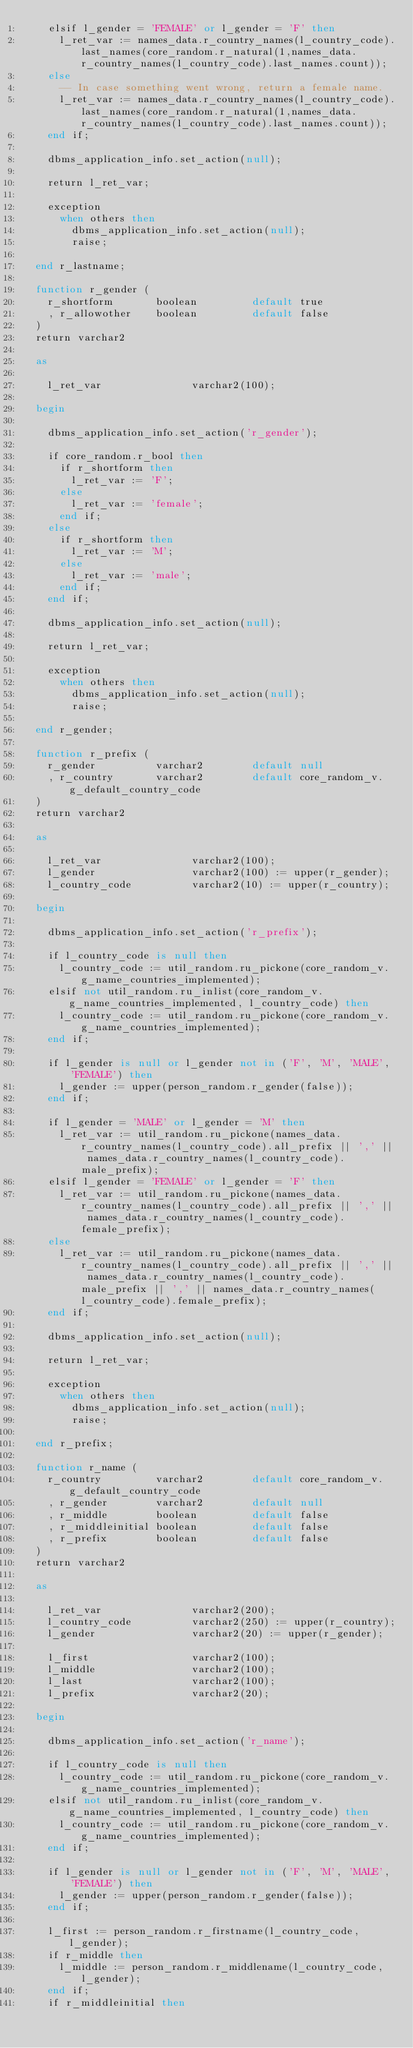Convert code to text. <code><loc_0><loc_0><loc_500><loc_500><_SQL_>    elsif l_gender = 'FEMALE' or l_gender = 'F' then
      l_ret_var := names_data.r_country_names(l_country_code).last_names(core_random.r_natural(1,names_data.r_country_names(l_country_code).last_names.count));
    else
      -- In case something went wrong, return a female name.
      l_ret_var := names_data.r_country_names(l_country_code).last_names(core_random.r_natural(1,names_data.r_country_names(l_country_code).last_names.count));
    end if;

    dbms_application_info.set_action(null);

    return l_ret_var;

    exception
      when others then
        dbms_application_info.set_action(null);
        raise;

  end r_lastname;

  function r_gender (
    r_shortform       boolean         default true
    , r_allowother    boolean         default false
  )
  return varchar2

  as

    l_ret_var               varchar2(100);

  begin

    dbms_application_info.set_action('r_gender');

    if core_random.r_bool then
      if r_shortform then
        l_ret_var := 'F';
      else
        l_ret_var := 'female';
      end if;
    else
      if r_shortform then
        l_ret_var := 'M';
      else
        l_ret_var := 'male';
      end if;
    end if;

    dbms_application_info.set_action(null);

    return l_ret_var;

    exception
      when others then
        dbms_application_info.set_action(null);
        raise;

  end r_gender;

  function r_prefix (
    r_gender          varchar2        default null
    , r_country       varchar2        default core_random_v.g_default_country_code
  )
  return varchar2

  as

    l_ret_var               varchar2(100);
    l_gender                varchar2(100) := upper(r_gender);
    l_country_code          varchar2(10) := upper(r_country);

  begin

    dbms_application_info.set_action('r_prefix');

    if l_country_code is null then
      l_country_code := util_random.ru_pickone(core_random_v.g_name_countries_implemented);
    elsif not util_random.ru_inlist(core_random_v.g_name_countries_implemented, l_country_code) then
      l_country_code := util_random.ru_pickone(core_random_v.g_name_countries_implemented);
    end if;

    if l_gender is null or l_gender not in ('F', 'M', 'MALE', 'FEMALE') then
      l_gender := upper(person_random.r_gender(false));
    end if;

    if l_gender = 'MALE' or l_gender = 'M' then
      l_ret_var := util_random.ru_pickone(names_data.r_country_names(l_country_code).all_prefix || ',' || names_data.r_country_names(l_country_code).male_prefix);
    elsif l_gender = 'FEMALE' or l_gender = 'F' then
      l_ret_var := util_random.ru_pickone(names_data.r_country_names(l_country_code).all_prefix || ',' || names_data.r_country_names(l_country_code).female_prefix);
    else
      l_ret_var := util_random.ru_pickone(names_data.r_country_names(l_country_code).all_prefix || ',' || names_data.r_country_names(l_country_code).male_prefix || ',' || names_data.r_country_names(l_country_code).female_prefix);
    end if;

    dbms_application_info.set_action(null);

    return l_ret_var;

    exception
      when others then
        dbms_application_info.set_action(null);
        raise;

  end r_prefix;

  function r_name (
    r_country         varchar2        default core_random_v.g_default_country_code
    , r_gender        varchar2        default null
    , r_middle        boolean         default false
    , r_middleinitial boolean         default false
    , r_prefix        boolean         default false
  )
  return varchar2

  as

    l_ret_var               varchar2(200);
    l_country_code          varchar2(250) := upper(r_country);
    l_gender                varchar2(20) := upper(r_gender);

    l_first                 varchar2(100);
    l_middle                varchar2(100);
    l_last                  varchar2(100);
    l_prefix                varchar2(20);

  begin

    dbms_application_info.set_action('r_name');

    if l_country_code is null then
      l_country_code := util_random.ru_pickone(core_random_v.g_name_countries_implemented);
    elsif not util_random.ru_inlist(core_random_v.g_name_countries_implemented, l_country_code) then
      l_country_code := util_random.ru_pickone(core_random_v.g_name_countries_implemented);
    end if;

    if l_gender is null or l_gender not in ('F', 'M', 'MALE', 'FEMALE') then
      l_gender := upper(person_random.r_gender(false));
    end if;

    l_first := person_random.r_firstname(l_country_code, l_gender);
    if r_middle then
      l_middle := person_random.r_middlename(l_country_code, l_gender);
    end if;
    if r_middleinitial then</code> 